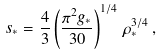Convert formula to latex. <formula><loc_0><loc_0><loc_500><loc_500>s _ { * } = \frac { 4 } { 3 } \left ( \frac { \pi ^ { 2 } g _ { * } } { 3 0 } \right ) ^ { 1 / 4 } \, \rho _ { * } ^ { 3 / 4 } \, ,</formula> 